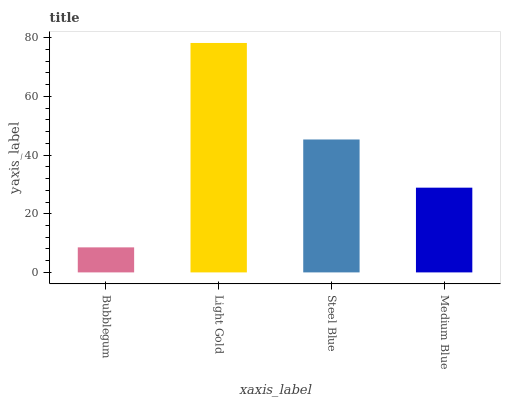Is Bubblegum the minimum?
Answer yes or no. Yes. Is Light Gold the maximum?
Answer yes or no. Yes. Is Steel Blue the minimum?
Answer yes or no. No. Is Steel Blue the maximum?
Answer yes or no. No. Is Light Gold greater than Steel Blue?
Answer yes or no. Yes. Is Steel Blue less than Light Gold?
Answer yes or no. Yes. Is Steel Blue greater than Light Gold?
Answer yes or no. No. Is Light Gold less than Steel Blue?
Answer yes or no. No. Is Steel Blue the high median?
Answer yes or no. Yes. Is Medium Blue the low median?
Answer yes or no. Yes. Is Light Gold the high median?
Answer yes or no. No. Is Bubblegum the low median?
Answer yes or no. No. 